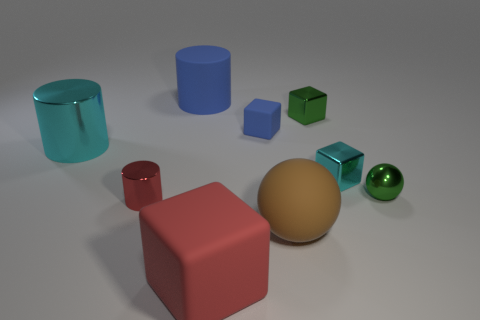Add 1 green metallic balls. How many objects exist? 10 Subtract all blue rubber cubes. How many cubes are left? 3 Subtract all yellow cylinders. How many gray balls are left? 0 Subtract all red shiny cylinders. Subtract all big cyan shiny cylinders. How many objects are left? 7 Add 4 small blue rubber objects. How many small blue rubber objects are left? 5 Add 8 small metallic spheres. How many small metallic spheres exist? 9 Subtract all red blocks. How many blocks are left? 3 Subtract 1 blue cubes. How many objects are left? 8 Subtract all blocks. How many objects are left? 5 Subtract 2 cylinders. How many cylinders are left? 1 